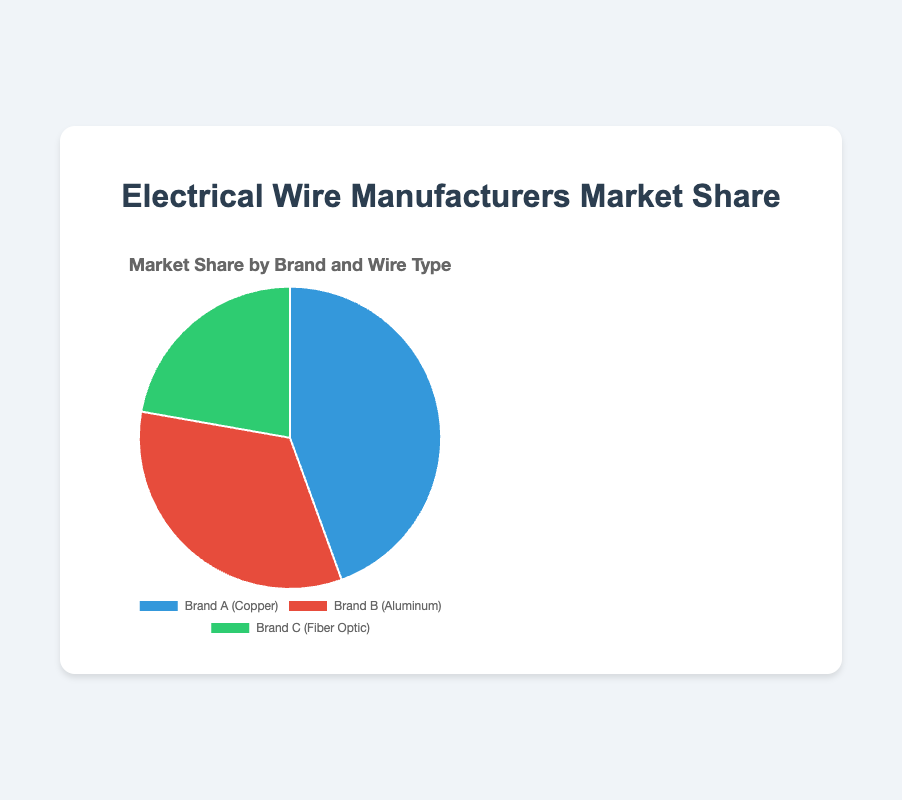What percentage of the market share is held by Brand A? The pie chart clearly shows that Brand A holds a market share of 40%. By looking at the segment labeled 'Brand A (Copper)', we can see it occupies 40% of the chart.
Answer: 40% Which brand has the smallest market share? By observing the size of the segments in the pie chart and their corresponding labels, Brand C (Fiber Optic) is the smallest segment, indicating it has the smallest market share of 20%.
Answer: Brand C What is the combined market share of Brand A and Brand C? Brand A has a market share of 40% and Brand C has a market share of 20%. Adding these percentages together gives 40% + 20% = 60%.
Answer: 60% How much more market share does Brand A have compared to Brand B? Brand A holds 40% of the market, while Brand B holds 30%. The difference is calculated as 40% - 30% = 10%.
Answer: 10% Which wire type has the highest market share? By looking at the pie chart, we see that 'Copper' associated with Brand A has the highest market share of 40%.
Answer: Copper What is the market share difference between the largest and smallest brands? Brand A has the largest market share at 40%, and Brand C has the smallest at 20%. The difference is 40% - 20% = 20%.
Answer: 20% If we combine the market share of Brand B and Brand C, does it exceed Brand A's market share? Adding Brand B's 30% and Brand C's 20% results in a combined market share of 30% + 20% = 50%, which is greater than Brand A's 40%.
Answer: Yes How much market share is held by brands that do not supply Copper wire? Brand B (Aluminum) has 30% and Brand C (Fiber Optic) has 20%. Adding these gives 30% + 20% = 50%.
Answer: 50% Which segment is represented by the green color in the pie chart? The green color corresponds to 'Brand C (Fiber Optic)' as observed in the chart's segments.
Answer: Brand C 